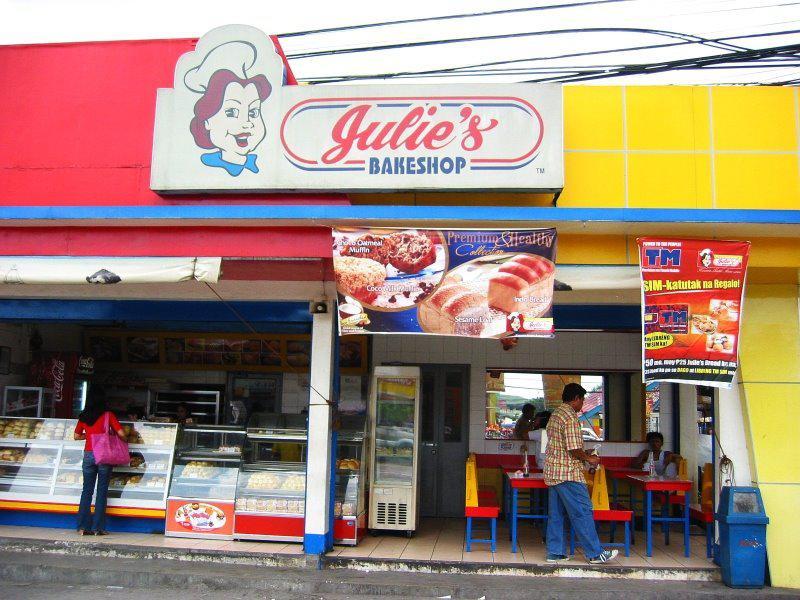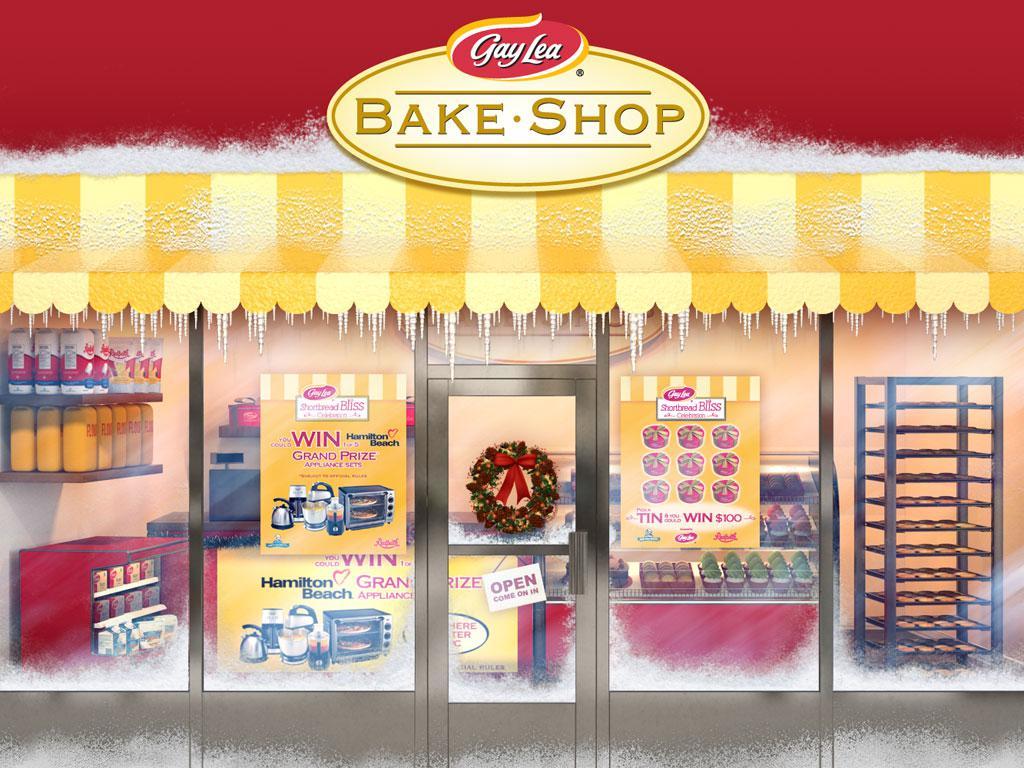The first image is the image on the left, the second image is the image on the right. Examine the images to the left and right. Is the description "These stores feature different names in each image of the set." accurate? Answer yes or no. Yes. 